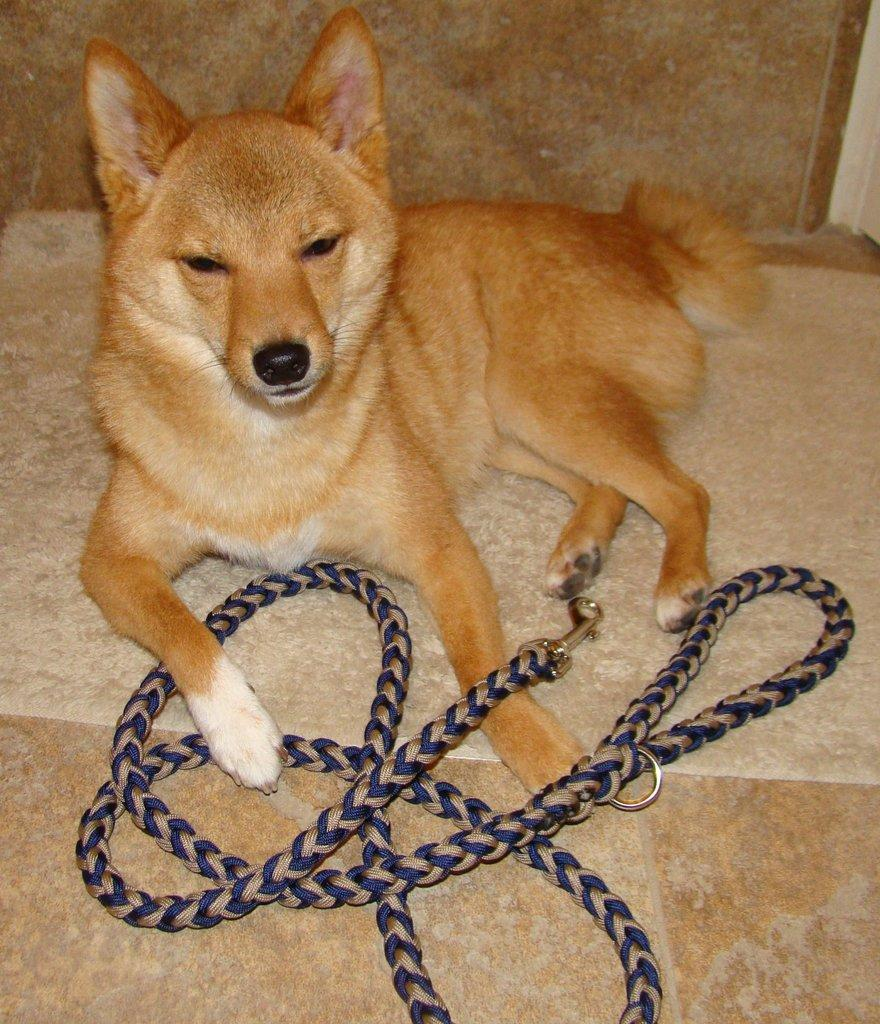What type of animal is in the image? There is a dog in the image. What is the dog sitting on? The dog is sitting on a mat. What object is in front of the dog? There is a rope in front of the dog. What is visible behind the dog? There is a wall behind the dog. What type of lettuce is the dog eating in the image? There is no lettuce present in the image; the dog is sitting on a mat with a rope in front and a wall behind. 